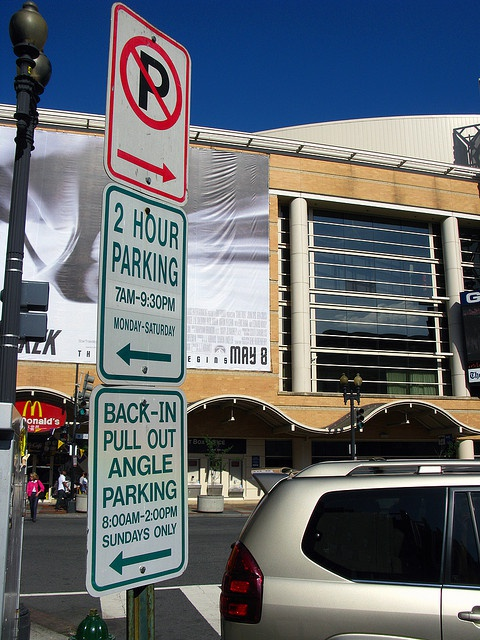Describe the objects in this image and their specific colors. I can see car in navy, black, gray, ivory, and darkgray tones, fire hydrant in navy, black, gray, darkgreen, and teal tones, people in navy, black, brown, and maroon tones, people in navy, black, lavender, maroon, and gray tones, and people in navy, black, gray, and darkgray tones in this image. 